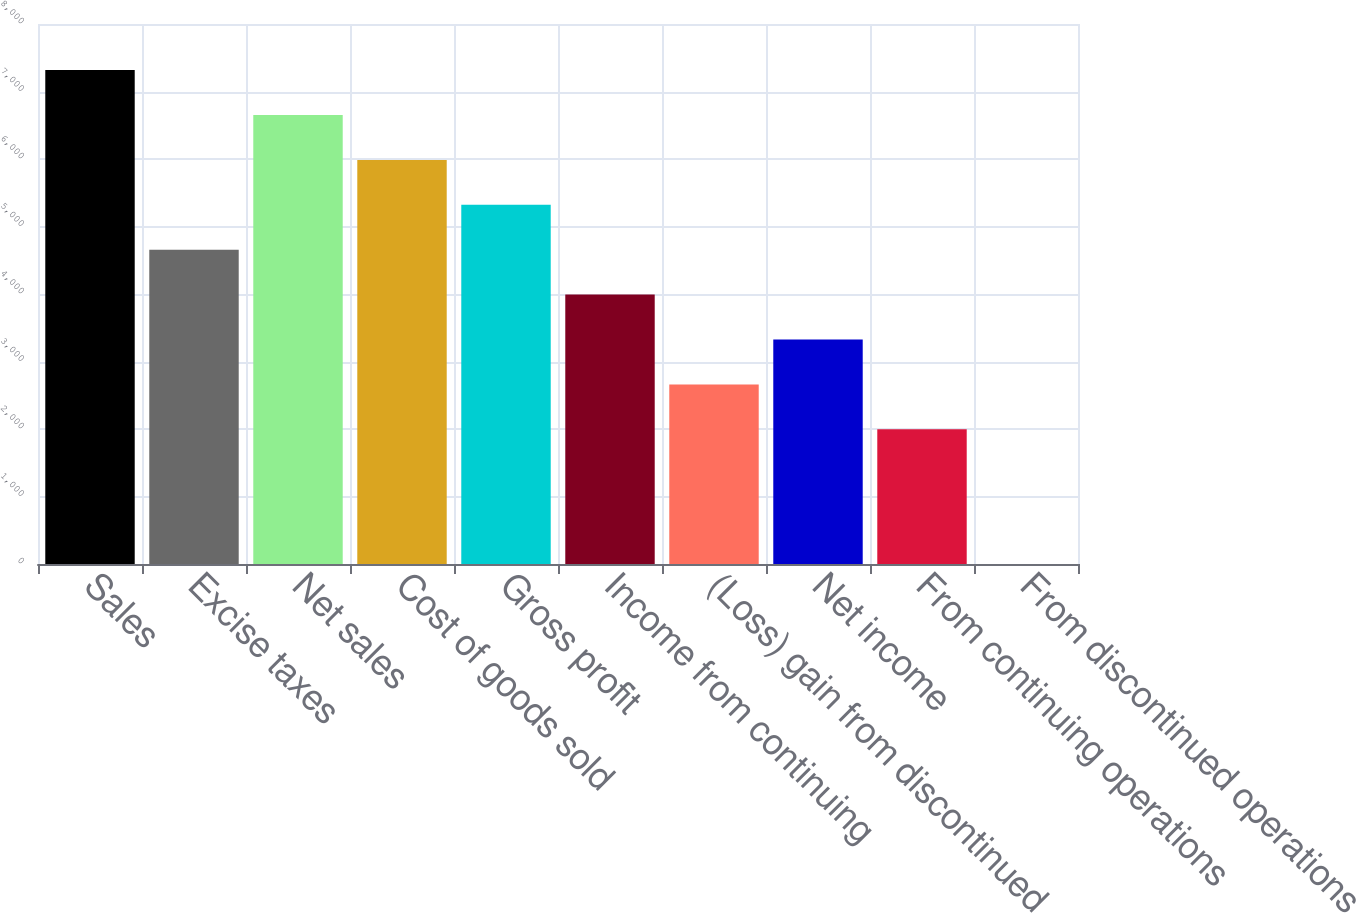Convert chart to OTSL. <chart><loc_0><loc_0><loc_500><loc_500><bar_chart><fcel>Sales<fcel>Excise taxes<fcel>Net sales<fcel>Cost of goods sold<fcel>Gross profit<fcel>Income from continuing<fcel>(Loss) gain from discontinued<fcel>Net income<fcel>From continuing operations<fcel>From discontinued operations<nl><fcel>7316.94<fcel>4656.26<fcel>6651.77<fcel>5986.6<fcel>5321.43<fcel>3991.09<fcel>2660.75<fcel>3325.92<fcel>1995.58<fcel>0.07<nl></chart> 